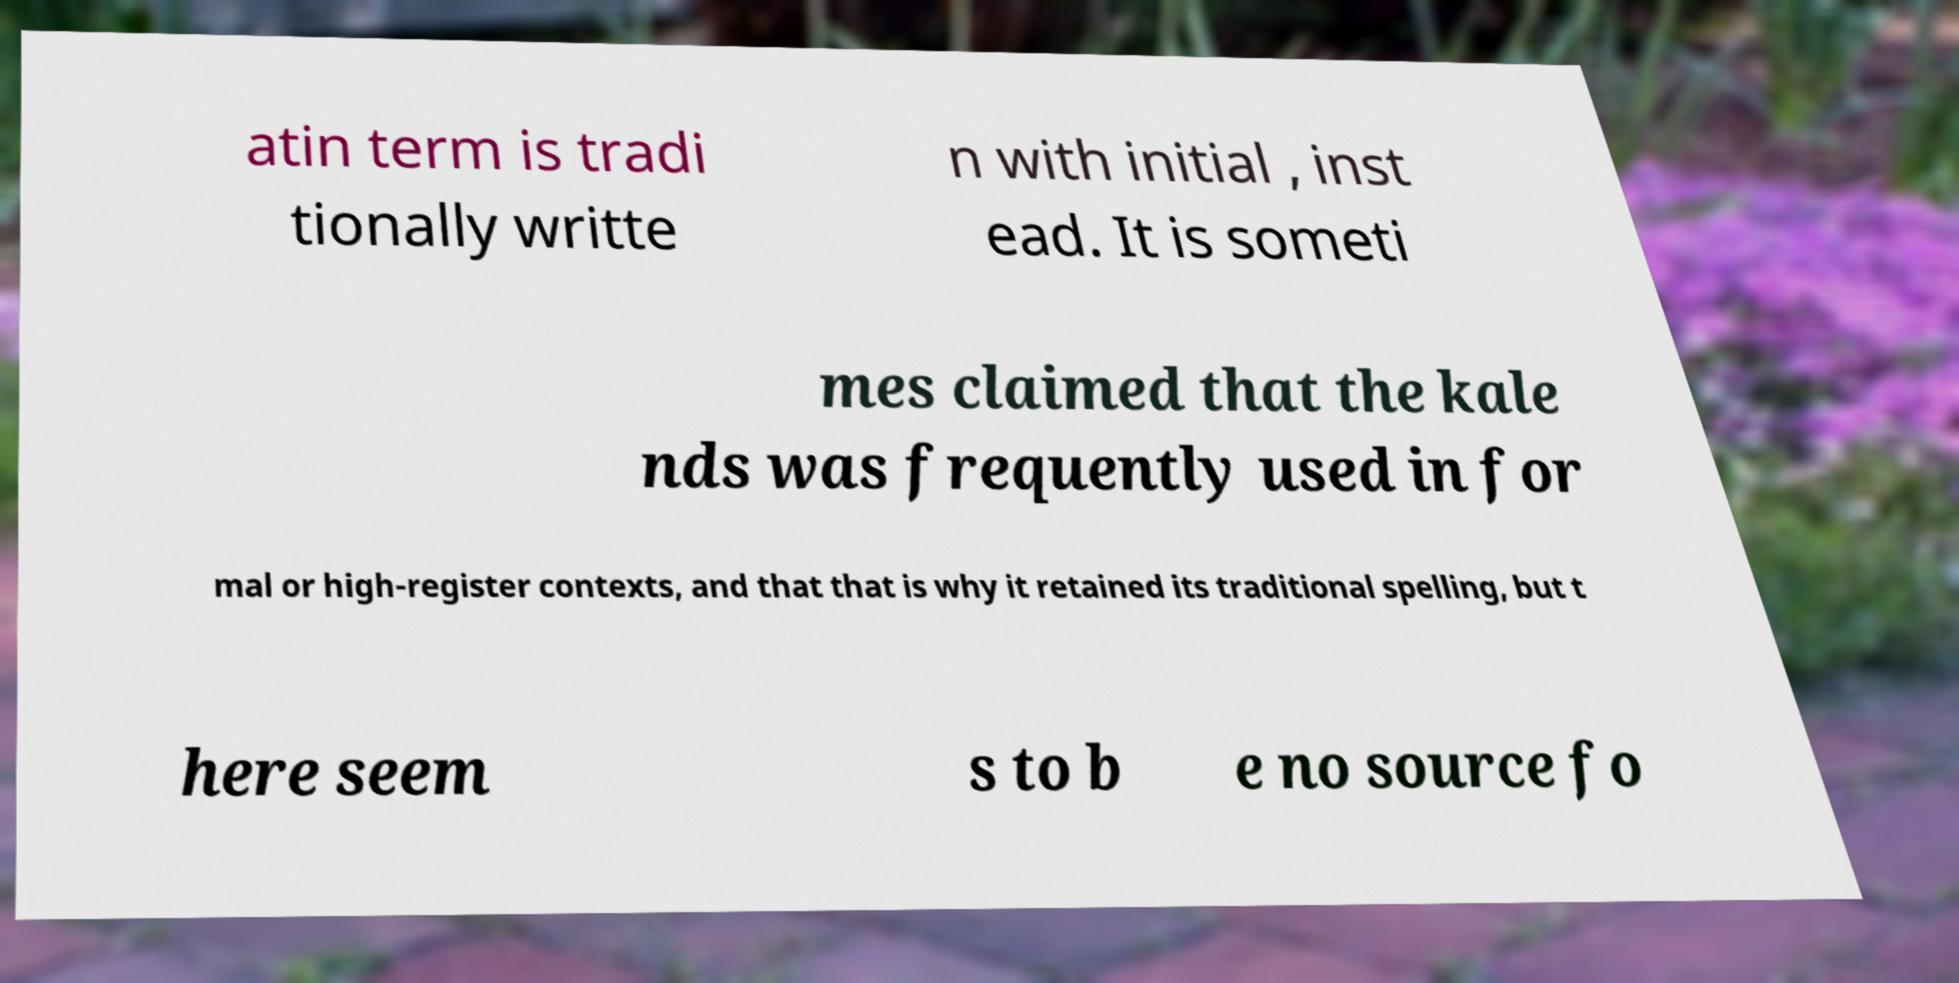I need the written content from this picture converted into text. Can you do that? atin term is tradi tionally writte n with initial , inst ead. It is someti mes claimed that the kale nds was frequently used in for mal or high-register contexts, and that that is why it retained its traditional spelling, but t here seem s to b e no source fo 